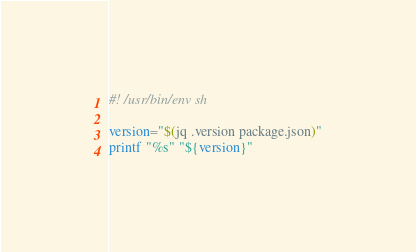<code> <loc_0><loc_0><loc_500><loc_500><_Bash_>#! /usr/bin/env sh

version="$(jq .version package.json)"
printf "%s" "${version}"
</code> 